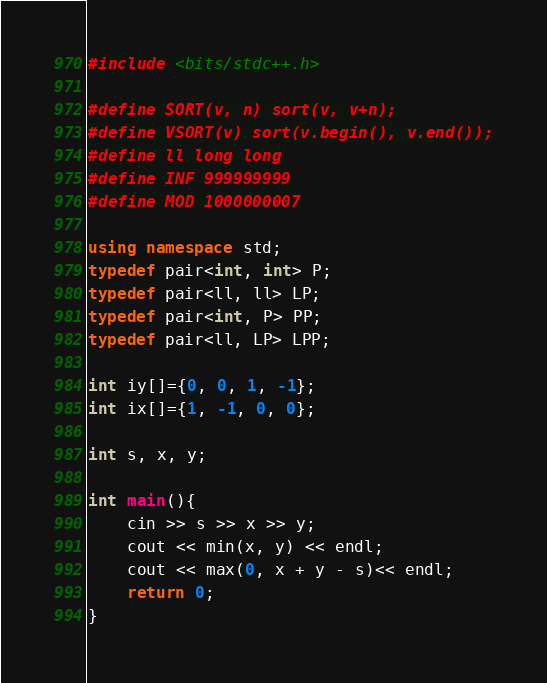<code> <loc_0><loc_0><loc_500><loc_500><_C++_>#include <bits/stdc++.h>

#define SORT(v, n) sort(v, v+n);
#define VSORT(v) sort(v.begin(), v.end());
#define ll long long
#define INF 999999999
#define MOD 1000000007

using namespace std;
typedef pair<int, int> P;
typedef pair<ll, ll> LP;
typedef pair<int, P> PP;
typedef pair<ll, LP> LPP;

int iy[]={0, 0, 1, -1};
int ix[]={1, -1, 0, 0};

int s, x, y;

int main(){
	cin >> s >> x >> y;
	cout << min(x, y) << endl;
	cout << max(0, x + y - s)<< endl;
	return 0;
}</code> 